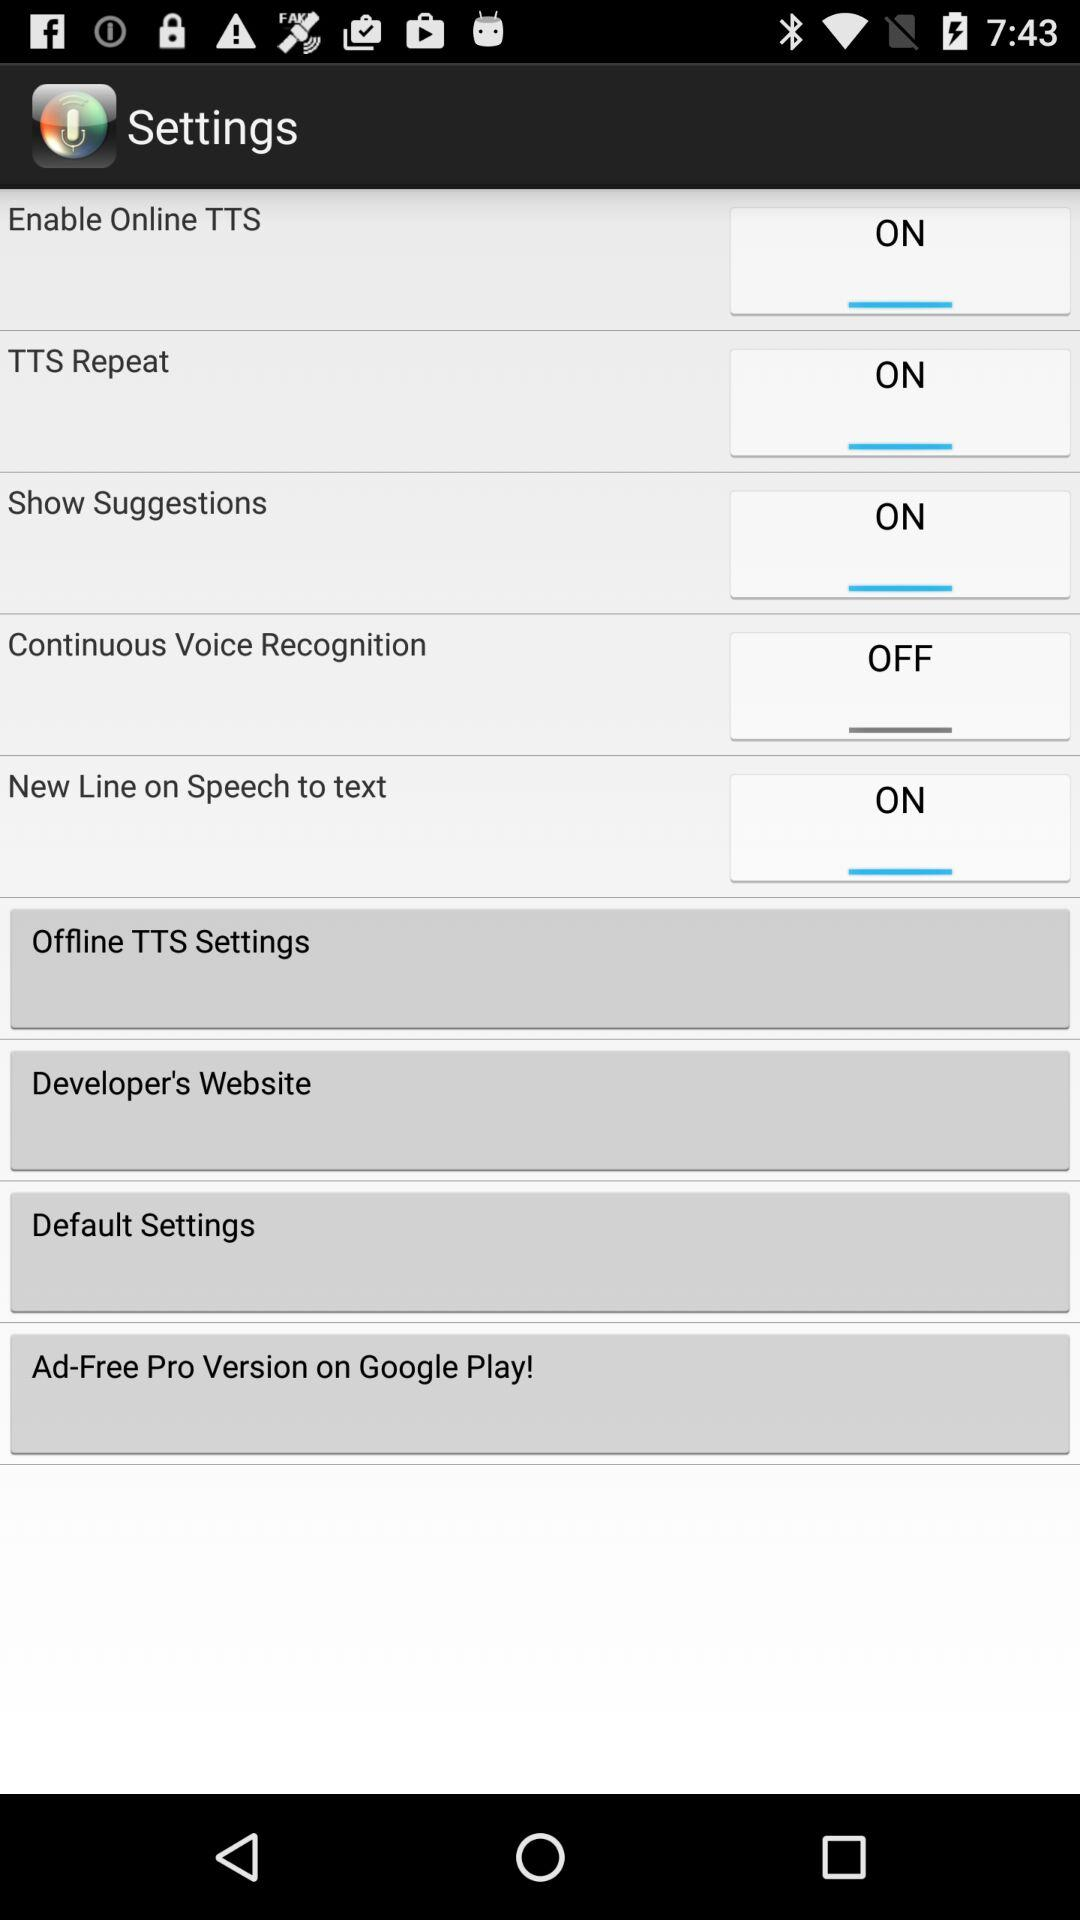What is the current status of "Show Suggestions"? The status is "ON". 